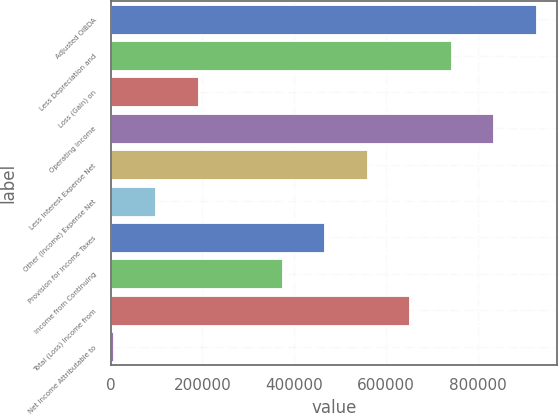Convert chart. <chart><loc_0><loc_0><loc_500><loc_500><bar_chart><fcel>Adjusted OIBDA<fcel>Less Depreciation and<fcel>Loss (Gain) on<fcel>Operating Income<fcel>Less Interest Expense Net<fcel>Other (Income) Expense Net<fcel>Provision for Income Taxes<fcel>Income from Continuing<fcel>Total (Loss) Income from<fcel>Net Income Attributable to<nl><fcel>926676<fcel>742322<fcel>189262<fcel>834499<fcel>557969<fcel>97084.8<fcel>465792<fcel>373615<fcel>650146<fcel>4908<nl></chart> 